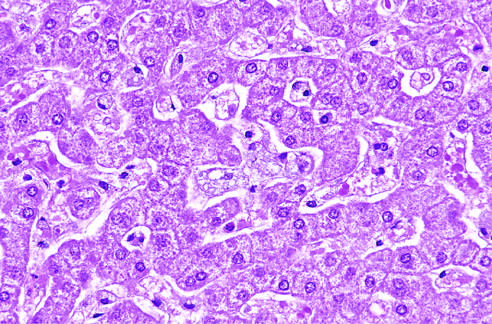what do the hepatocytes and kupffer cells have resulting from deposition of lipids?
Answer the question using a single word or phrase. A foamy 